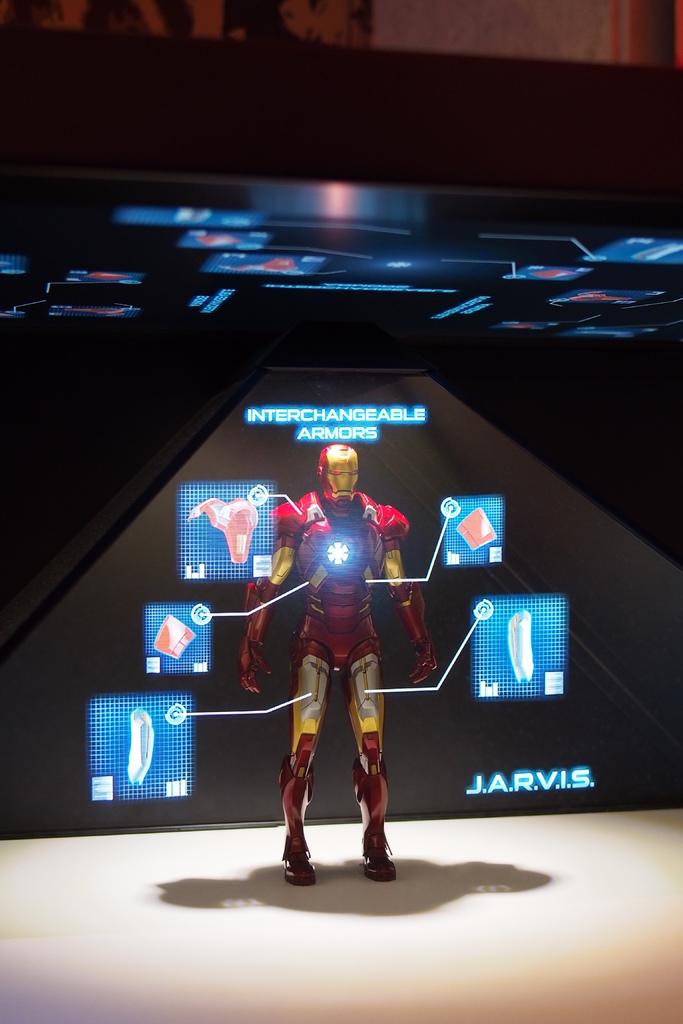What is a key feature of this armor?
Your answer should be compact. Interchangeable. What are the initials?
Your answer should be compact. J.a.r.v.i.s. 